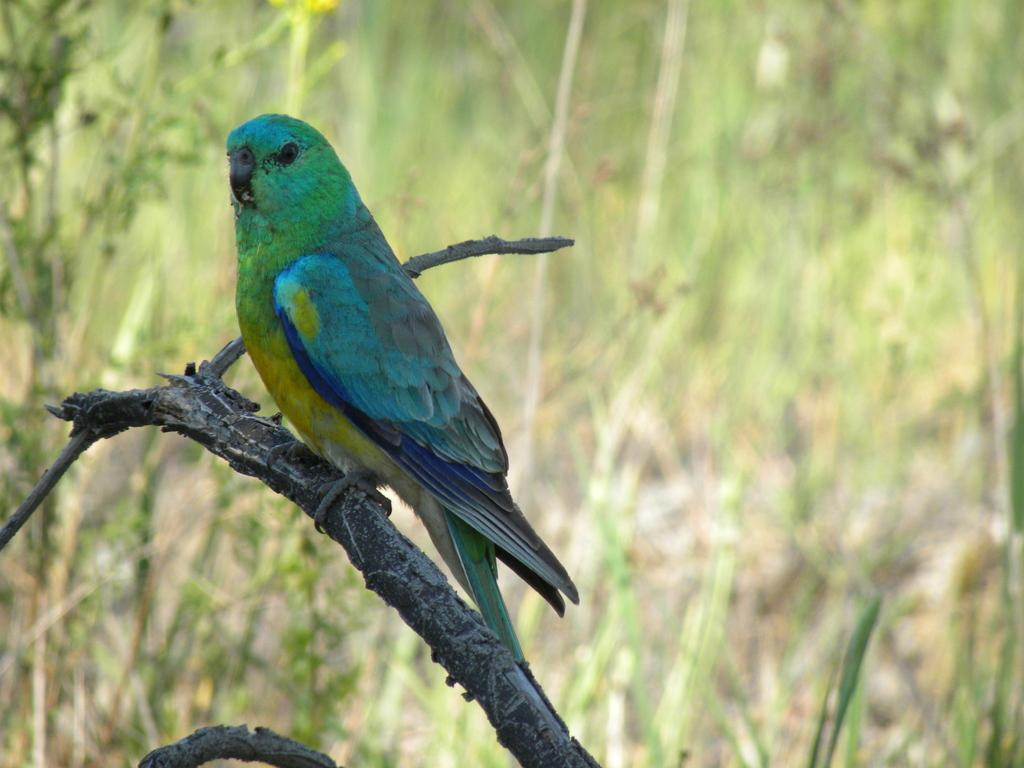What type of animal can be seen in the image? There is a bird in the image. Where is the bird located? The bird is standing on a branch. Can you describe the background of the image? The background of the image is blurry. What type of good-bye is the bird giving in the image? There is no indication of a good-bye in the image; the bird is simply standing on a branch. 